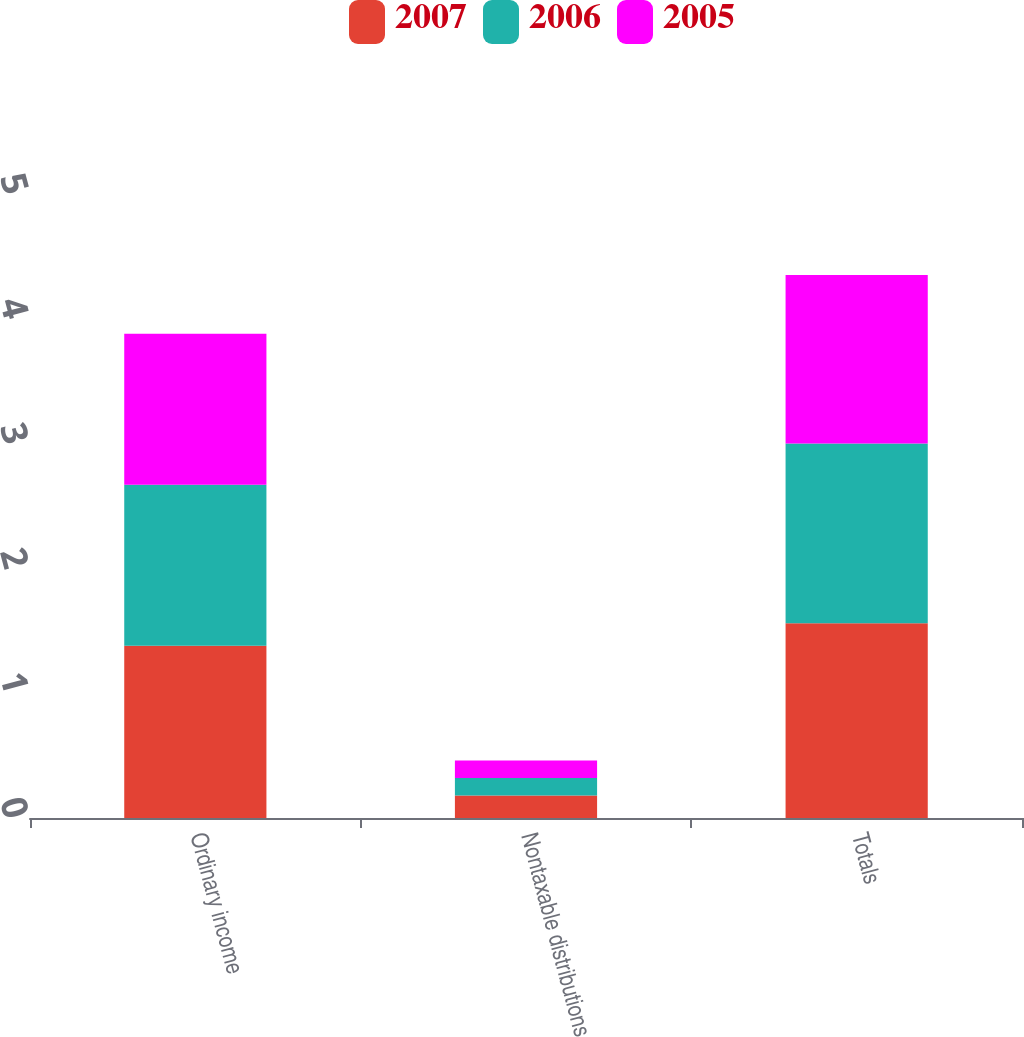<chart> <loc_0><loc_0><loc_500><loc_500><stacked_bar_chart><ecel><fcel>Ordinary income<fcel>Nontaxable distributions<fcel>Totals<nl><fcel>2007<fcel>1.38<fcel>0.18<fcel>1.56<nl><fcel>2006<fcel>1.29<fcel>0.14<fcel>1.44<nl><fcel>2005<fcel>1.21<fcel>0.14<fcel>1.35<nl></chart> 